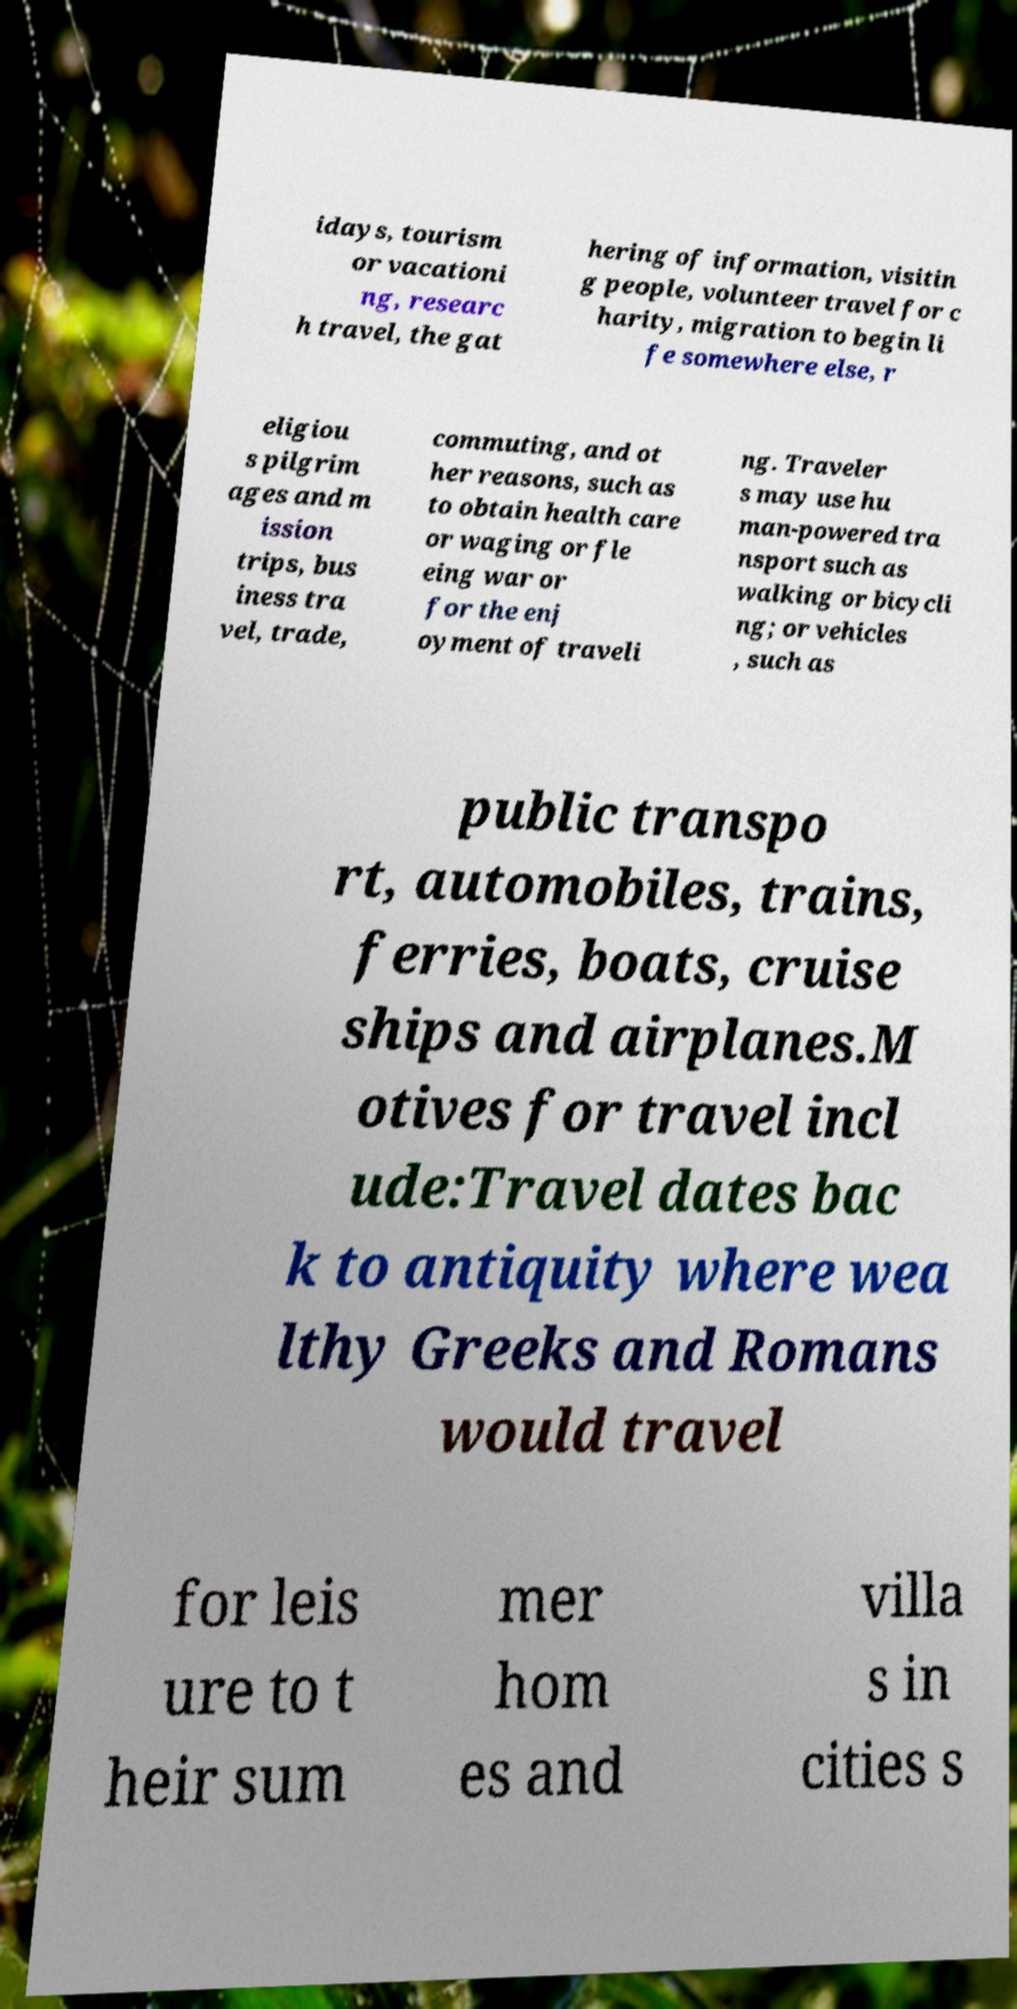For documentation purposes, I need the text within this image transcribed. Could you provide that? idays, tourism or vacationi ng, researc h travel, the gat hering of information, visitin g people, volunteer travel for c harity, migration to begin li fe somewhere else, r eligiou s pilgrim ages and m ission trips, bus iness tra vel, trade, commuting, and ot her reasons, such as to obtain health care or waging or fle eing war or for the enj oyment of traveli ng. Traveler s may use hu man-powered tra nsport such as walking or bicycli ng; or vehicles , such as public transpo rt, automobiles, trains, ferries, boats, cruise ships and airplanes.M otives for travel incl ude:Travel dates bac k to antiquity where wea lthy Greeks and Romans would travel for leis ure to t heir sum mer hom es and villa s in cities s 